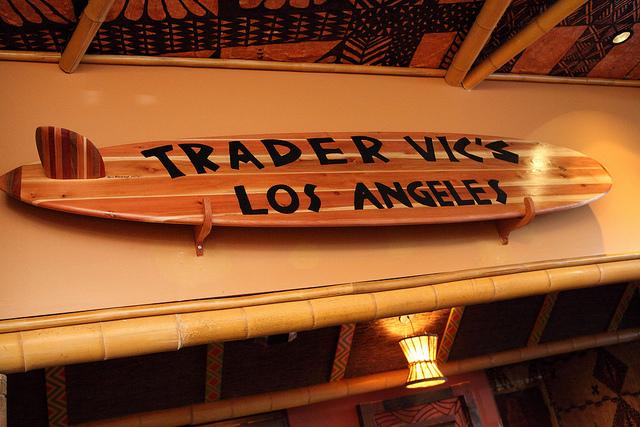What kind of board is this?
Keep it brief. Surfboard. Is this someone's living room?
Be succinct. No. What is the image painted on this board?
Short answer required. Trader vic's los angeles. What is the name of the establishment in which this board is hanging?
Short answer required. Trader vic's. What type of board is the business name written on?
Give a very brief answer. Surfboard. What color is the board?
Short answer required. Brown. 